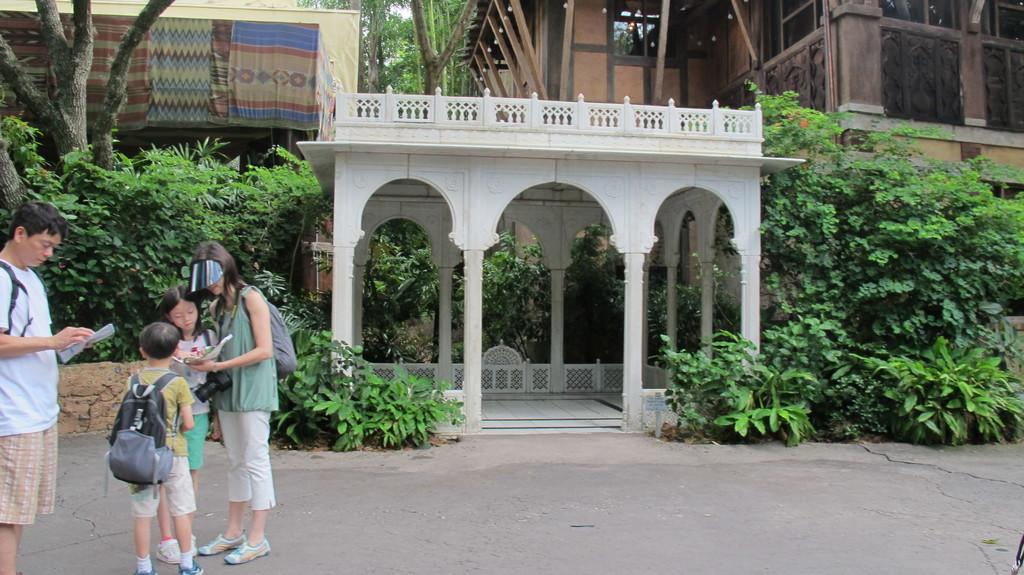How many people are present in the image? There are four people in the image: a man, a woman, and two kids. Where are the people standing in the image? The people are standing on the road on the left side of the image. What can be seen in the background of the image? There is a building in the background of the image. What is in front of the building? There are many plants and trees in front of the building. What type of collar can be seen on the wilderness in the image? There is no wilderness or collar present in the image. 